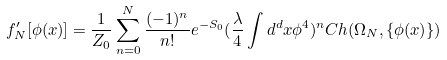Convert formula to latex. <formula><loc_0><loc_0><loc_500><loc_500>f _ { N } ^ { \prime } [ \phi ( x ) ] = \frac { 1 } { Z _ { 0 } } \sum _ { n = 0 } ^ { N } \frac { ( - 1 ) ^ { n } } { n ! } e ^ { - S _ { 0 } } ( \frac { \lambda } { 4 } \int d ^ { d } x \phi ^ { 4 } ) ^ { n } C h ( \Omega _ { N } , \{ \phi ( x ) \} )</formula> 